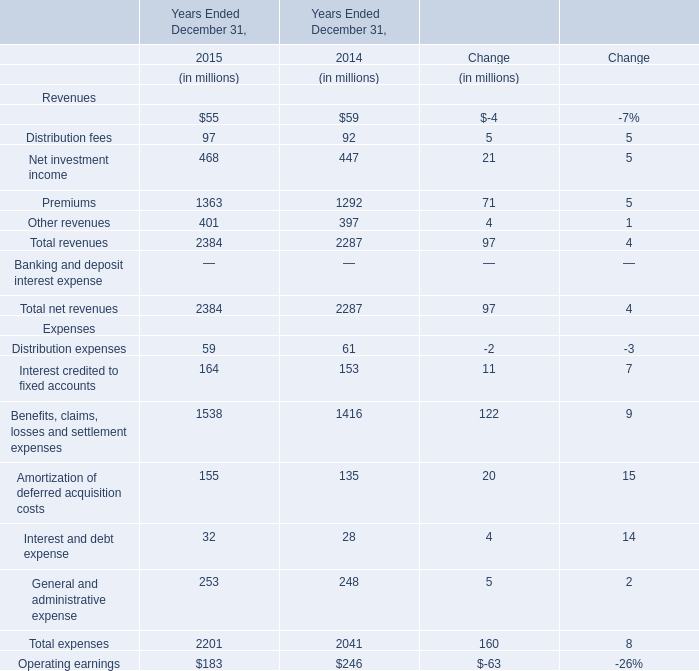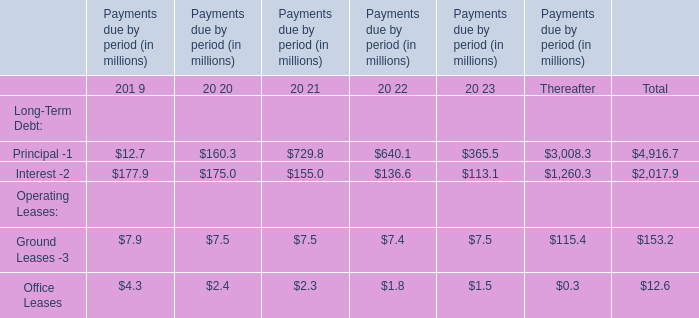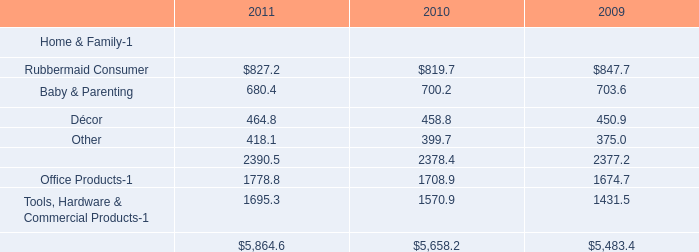What is the proportion of Distribution fees to the total in 2015? 
Computations: (97 / 2384)
Answer: 0.04069. 